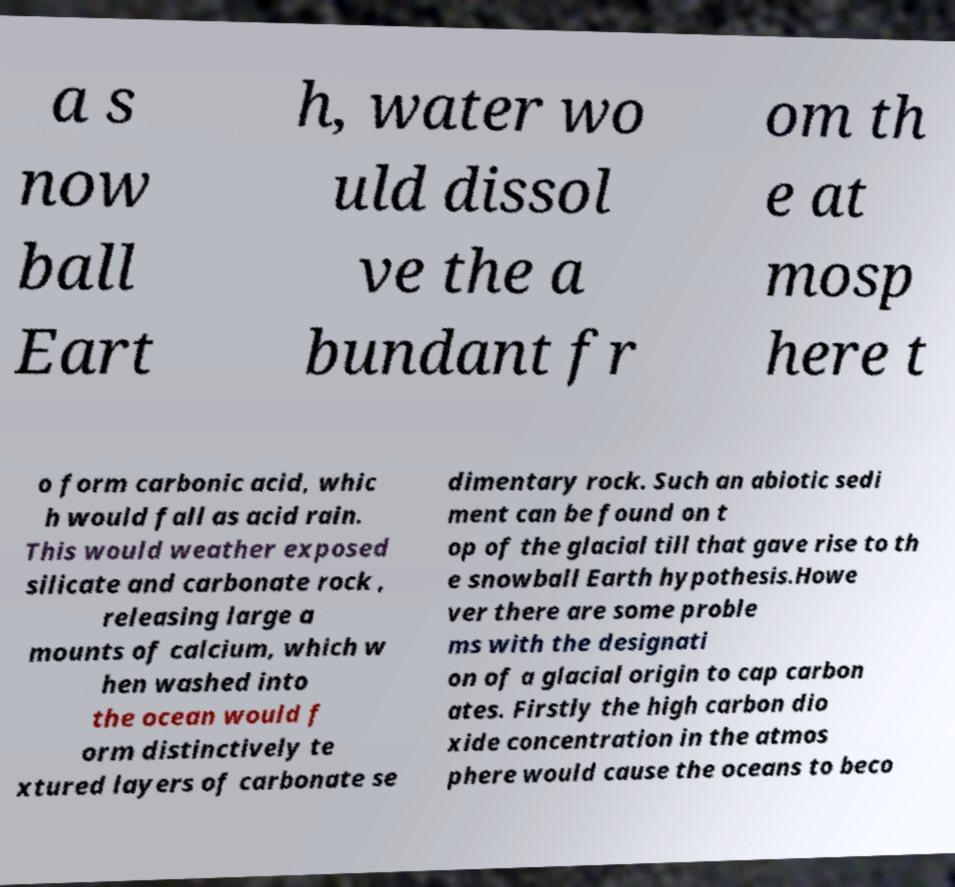Could you extract and type out the text from this image? a s now ball Eart h, water wo uld dissol ve the a bundant fr om th e at mosp here t o form carbonic acid, whic h would fall as acid rain. This would weather exposed silicate and carbonate rock , releasing large a mounts of calcium, which w hen washed into the ocean would f orm distinctively te xtured layers of carbonate se dimentary rock. Such an abiotic sedi ment can be found on t op of the glacial till that gave rise to th e snowball Earth hypothesis.Howe ver there are some proble ms with the designati on of a glacial origin to cap carbon ates. Firstly the high carbon dio xide concentration in the atmos phere would cause the oceans to beco 